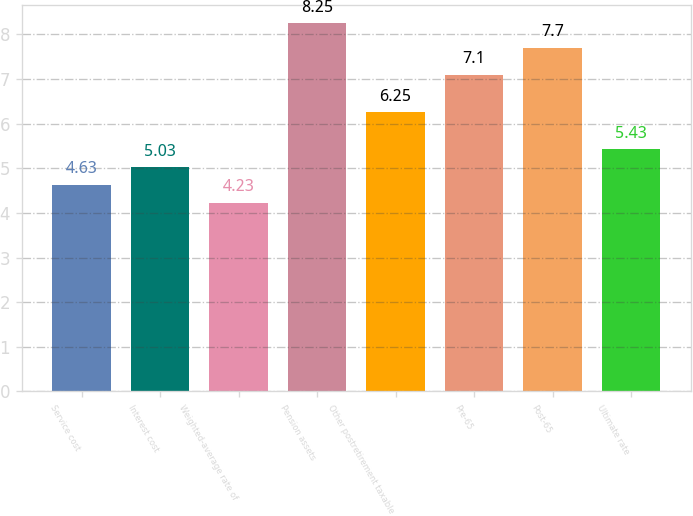<chart> <loc_0><loc_0><loc_500><loc_500><bar_chart><fcel>Service cost<fcel>Interest cost<fcel>Weighted-average rate of<fcel>Pension assets<fcel>Other postretirement taxable<fcel>Pre-65<fcel>Post-65<fcel>Ultimate rate<nl><fcel>4.63<fcel>5.03<fcel>4.23<fcel>8.25<fcel>6.25<fcel>7.1<fcel>7.7<fcel>5.43<nl></chart> 